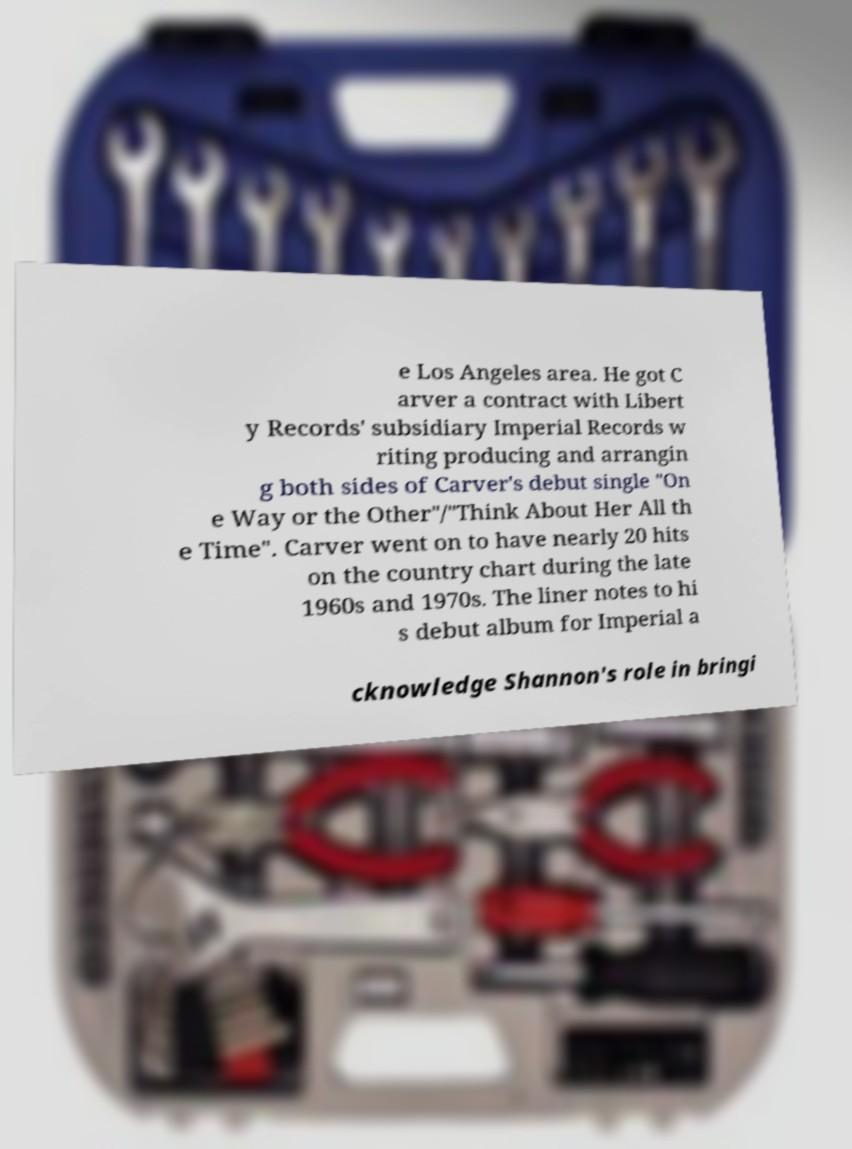Can you read and provide the text displayed in the image?This photo seems to have some interesting text. Can you extract and type it out for me? e Los Angeles area. He got C arver a contract with Libert y Records' subsidiary Imperial Records w riting producing and arrangin g both sides of Carver's debut single "On e Way or the Other"/"Think About Her All th e Time". Carver went on to have nearly 20 hits on the country chart during the late 1960s and 1970s. The liner notes to hi s debut album for Imperial a cknowledge Shannon's role in bringi 